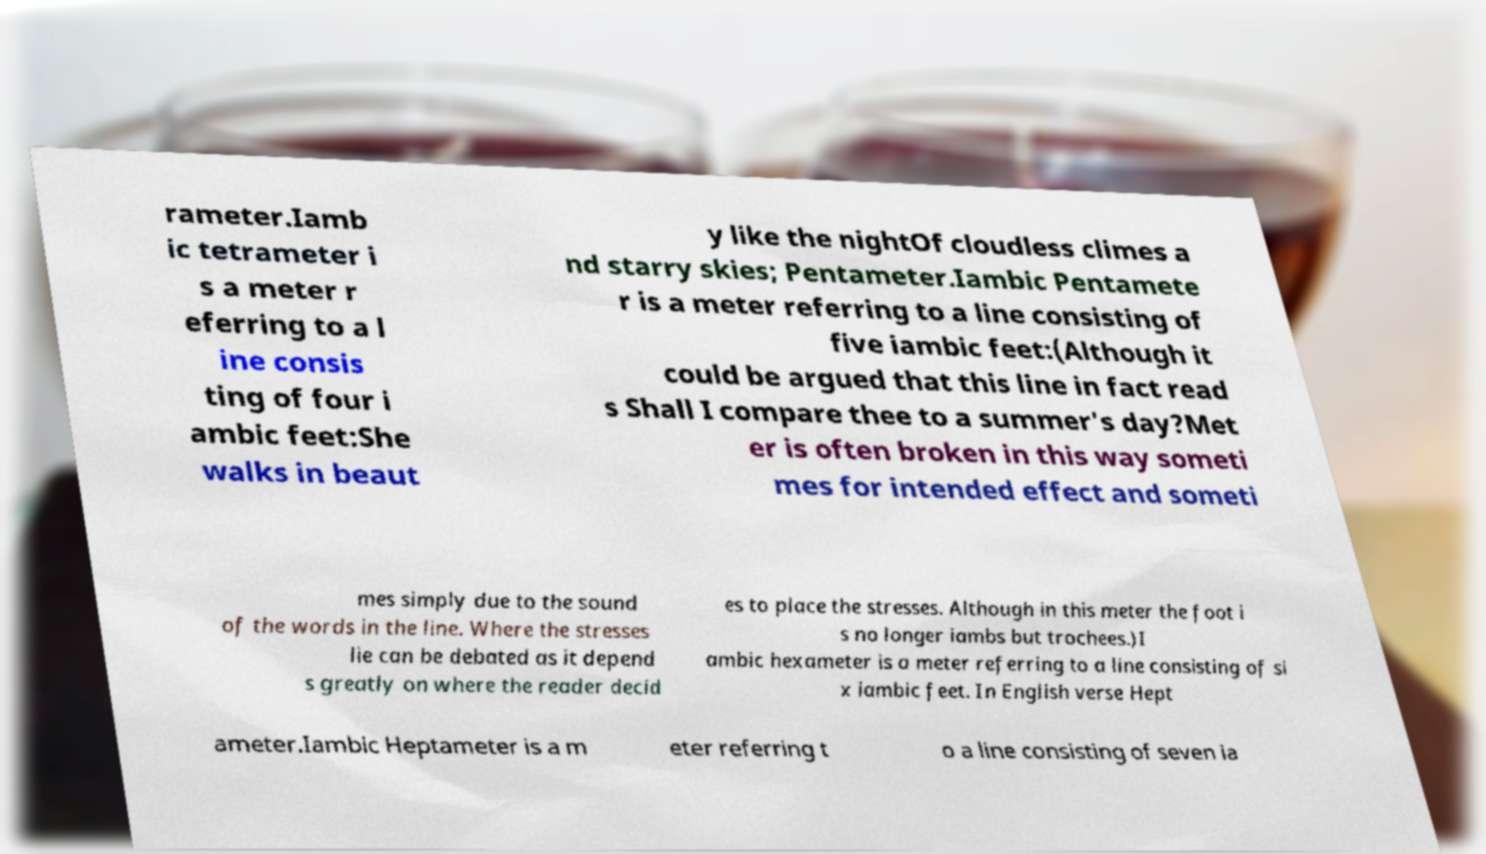Please identify and transcribe the text found in this image. rameter.Iamb ic tetrameter i s a meter r eferring to a l ine consis ting of four i ambic feet:She walks in beaut y like the nightOf cloudless climes a nd starry skies; Pentameter.Iambic Pentamete r is a meter referring to a line consisting of five iambic feet:(Although it could be argued that this line in fact read s Shall I compare thee to a summer's day?Met er is often broken in this way someti mes for intended effect and someti mes simply due to the sound of the words in the line. Where the stresses lie can be debated as it depend s greatly on where the reader decid es to place the stresses. Although in this meter the foot i s no longer iambs but trochees.)I ambic hexameter is a meter referring to a line consisting of si x iambic feet. In English verse Hept ameter.Iambic Heptameter is a m eter referring t o a line consisting of seven ia 